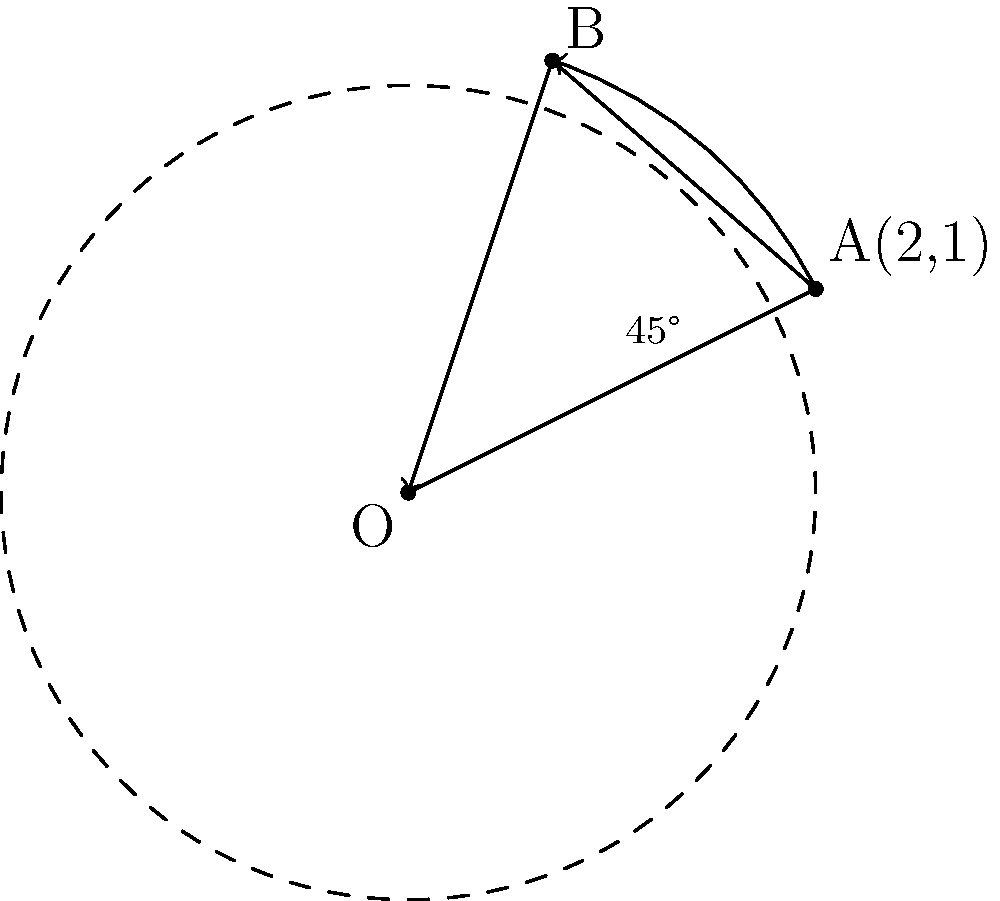In an embedded systems project, you need to implement a rotation algorithm for a 2D object tracking system. Given a point A(2,1) in the xy-plane, calculate its new coordinates after a 45° counterclockwise rotation around the origin O(0,0). Round your answer to two decimal places. To solve this problem, we'll use the rotation matrix for a counterclockwise rotation by angle θ:

$$ R(\theta) = \begin{bmatrix} \cos\theta & -\sin\theta \\ \sin\theta & \cos\theta \end{bmatrix} $$

Step 1: Identify the given information
- Initial point: $A(2,1)$
- Rotation angle: $\theta = 45°$
- Center of rotation: $O(0,0)$

Step 2: Convert 45° to radians
$45° = \frac{\pi}{4}$ radians

Step 3: Calculate $\cos(45°)$ and $\sin(45°)$
$\cos(45°) = \frac{\sqrt{2}}{2} \approx 0.7071$
$\sin(45°) = \frac{\sqrt{2}}{2} \approx 0.7071$

Step 4: Apply the rotation matrix
$$ \begin{bmatrix} x' \\ y' \end{bmatrix} = \begin{bmatrix} \cos(45°) & -\sin(45°) \\ \sin(45°) & \cos(45°) \end{bmatrix} \begin{bmatrix} 2 \\ 1 \end{bmatrix} $$

$$ \begin{bmatrix} x' \\ y' \end{bmatrix} = \begin{bmatrix} 0.7071 & -0.7071 \\ 0.7071 & 0.7071 \end{bmatrix} \begin{bmatrix} 2 \\ 1 \end{bmatrix} $$

Step 5: Multiply the matrices
$x' = (0.7071 \times 2) + (-0.7071 \times 1) = 0.7071$
$y' = (0.7071 \times 2) + (0.7071 \times 1) = 2.1213$

Step 6: Round to two decimal places
$x' \approx 0.71$
$y' \approx 2.12$

Therefore, the new coordinates of point A after a 45° counterclockwise rotation around the origin are approximately (0.71, 2.12).
Answer: (0.71, 2.12) 